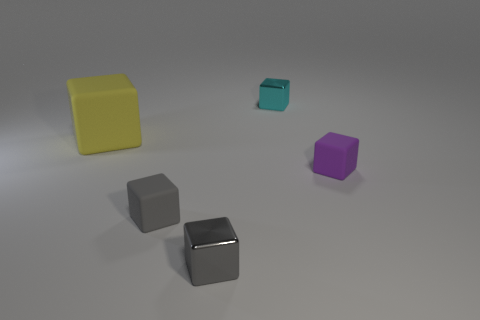Subtract 2 blocks. How many blocks are left? 3 Subtract all blue blocks. Subtract all red balls. How many blocks are left? 5 Add 3 small gray rubber cubes. How many objects exist? 8 Add 5 big yellow blocks. How many big yellow blocks exist? 6 Subtract 0 purple cylinders. How many objects are left? 5 Subtract all large rubber objects. Subtract all purple matte things. How many objects are left? 3 Add 1 matte blocks. How many matte blocks are left? 4 